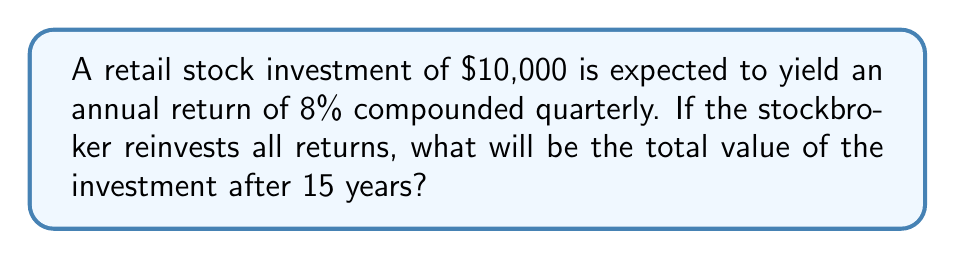Show me your answer to this math problem. To solve this problem, we'll use the compound interest formula:

$$A = P(1 + \frac{r}{n})^{nt}$$

Where:
$A$ = Final amount
$P$ = Principal (initial investment)
$r$ = Annual interest rate (as a decimal)
$n$ = Number of times interest is compounded per year
$t$ = Number of years

Given:
$P = \$10,000$
$r = 0.08$ (8% expressed as a decimal)
$n = 4$ (compounded quarterly)
$t = 15$ years

Step 1: Substitute the values into the formula:

$$A = 10000(1 + \frac{0.08}{4})^{4 \times 15}$$

Step 2: Simplify the expression inside the parentheses:

$$A = 10000(1 + 0.02)^{60}$$

Step 3: Calculate the power:

$$A = 10000(1.02)^{60}$$

Step 4: Use a calculator to compute the final result:

$$A = 10000 \times 3.2810...$$
$$A = 32810.00...$$

Step 5: Round to the nearest cent:

$$A = \$32,810.00$$
Answer: $32,810.00 